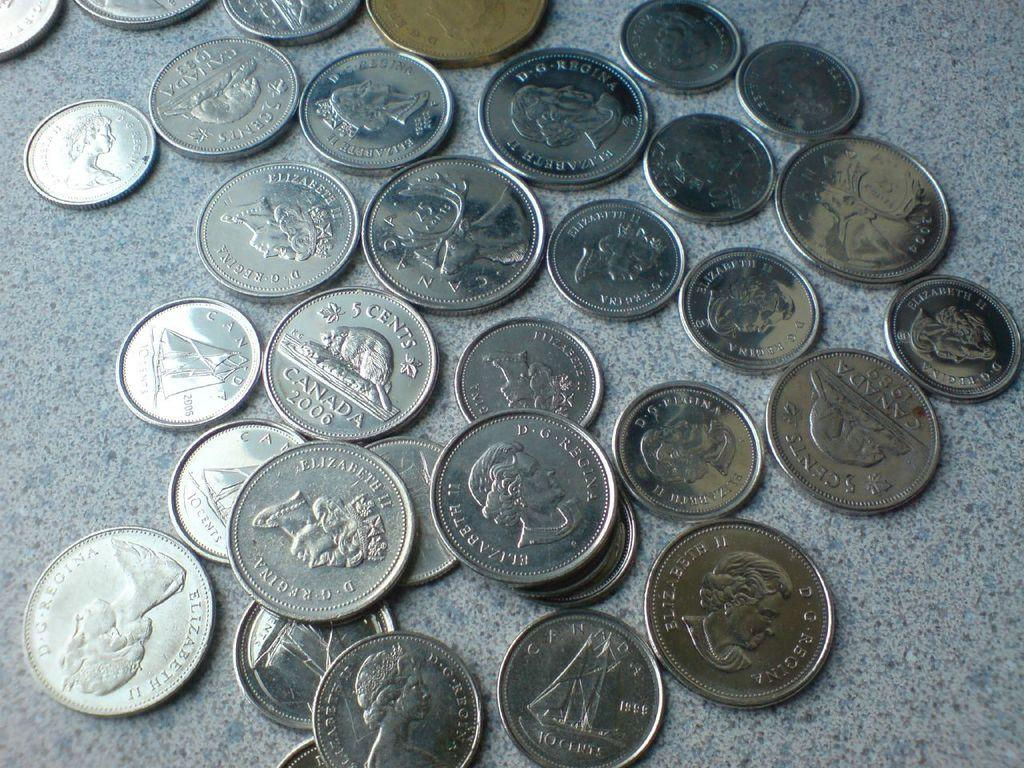Provide a one-sentence caption for the provided image. Various coins from Canada from the late 1900's. 